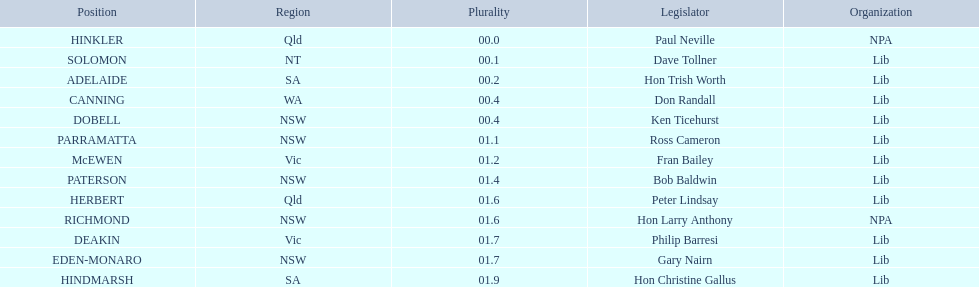How many members in total? 13. 